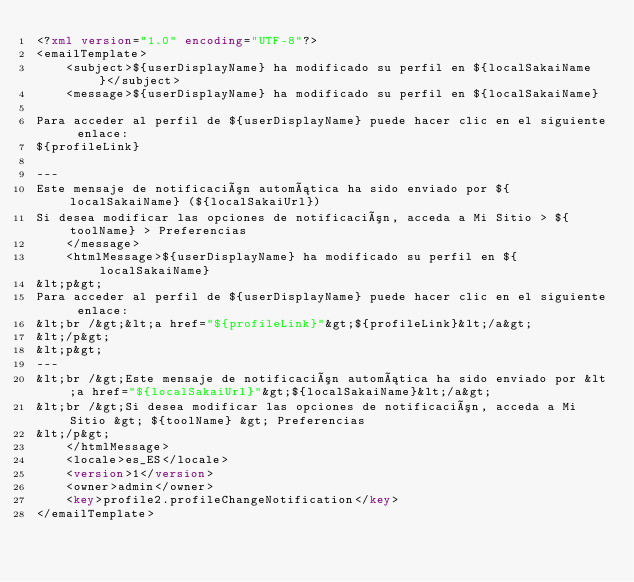<code> <loc_0><loc_0><loc_500><loc_500><_XML_><?xml version="1.0" encoding="UTF-8"?>
<emailTemplate>
	<subject>${userDisplayName} ha modificado su perfil en ${localSakaiName}</subject>
	<message>${userDisplayName} ha modificado su perfil en ${localSakaiName}

Para acceder al perfil de ${userDisplayName} puede hacer clic en el siguiente enlace:
${profileLink}

---
Este mensaje de notificación automática ha sido enviado por ${localSakaiName} (${localSakaiUrl})
Si desea modificar las opciones de notificación, acceda a Mi Sitio > ${toolName} > Preferencias
	</message>
	<htmlMessage>${userDisplayName} ha modificado su perfil en ${localSakaiName}
&lt;p&gt;
Para acceder al perfil de ${userDisplayName} puede hacer clic en el siguiente enlace:
&lt;br /&gt;&lt;a href="${profileLink}"&gt;${profileLink}&lt;/a&gt;
&lt;/p&gt;
&lt;p&gt;
---
&lt;br /&gt;Este mensaje de notificación automática ha sido enviado por &lt;a href="${localSakaiUrl}"&gt;${localSakaiName}&lt;/a&gt;
&lt;br /&gt;Si desea modificar las opciones de notificación, acceda a Mi Sitio &gt; ${toolName} &gt; Preferencias
&lt;/p&gt;
	</htmlMessage>
	<locale>es_ES</locale>
	<version>1</version>
	<owner>admin</owner>
	<key>profile2.profileChangeNotification</key>
</emailTemplate></code> 